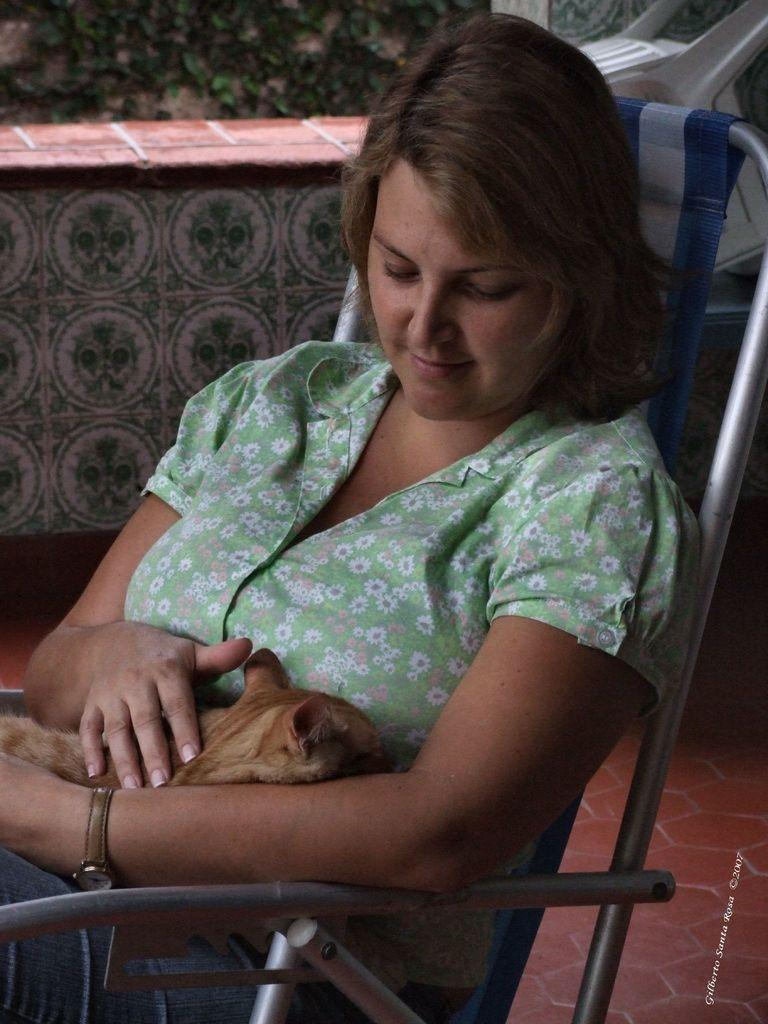Who is present in the image? There is a woman in the image. What is the woman holding? The woman is holding a cat. What is the woman's position in the image? The woman is sitting on a chair. What is the woman wearing? The woman is wearing a green dress. What can be seen in the background of the image? There is a wall and plants visible in the background of the image. What type of corn can be seen growing on the bridge in the image? There is no corn or bridge present in the image; it features a woman holding a cat and sitting on a chair with a background of a wall and plants. 